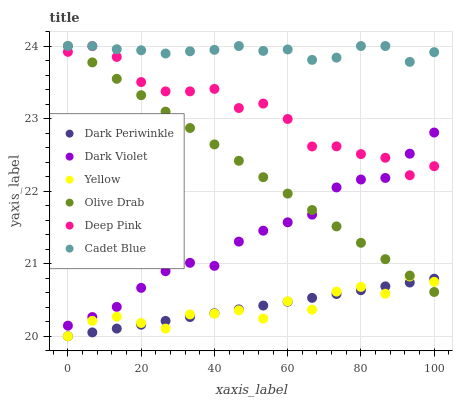Does Yellow have the minimum area under the curve?
Answer yes or no. Yes. Does Cadet Blue have the maximum area under the curve?
Answer yes or no. Yes. Does Deep Pink have the minimum area under the curve?
Answer yes or no. No. Does Deep Pink have the maximum area under the curve?
Answer yes or no. No. Is Dark Periwinkle the smoothest?
Answer yes or no. Yes. Is Yellow the roughest?
Answer yes or no. Yes. Is Deep Pink the smoothest?
Answer yes or no. No. Is Deep Pink the roughest?
Answer yes or no. No. Does Yellow have the lowest value?
Answer yes or no. Yes. Does Deep Pink have the lowest value?
Answer yes or no. No. Does Olive Drab have the highest value?
Answer yes or no. Yes. Does Yellow have the highest value?
Answer yes or no. No. Is Yellow less than Cadet Blue?
Answer yes or no. Yes. Is Deep Pink greater than Yellow?
Answer yes or no. Yes. Does Dark Violet intersect Olive Drab?
Answer yes or no. Yes. Is Dark Violet less than Olive Drab?
Answer yes or no. No. Is Dark Violet greater than Olive Drab?
Answer yes or no. No. Does Yellow intersect Cadet Blue?
Answer yes or no. No. 